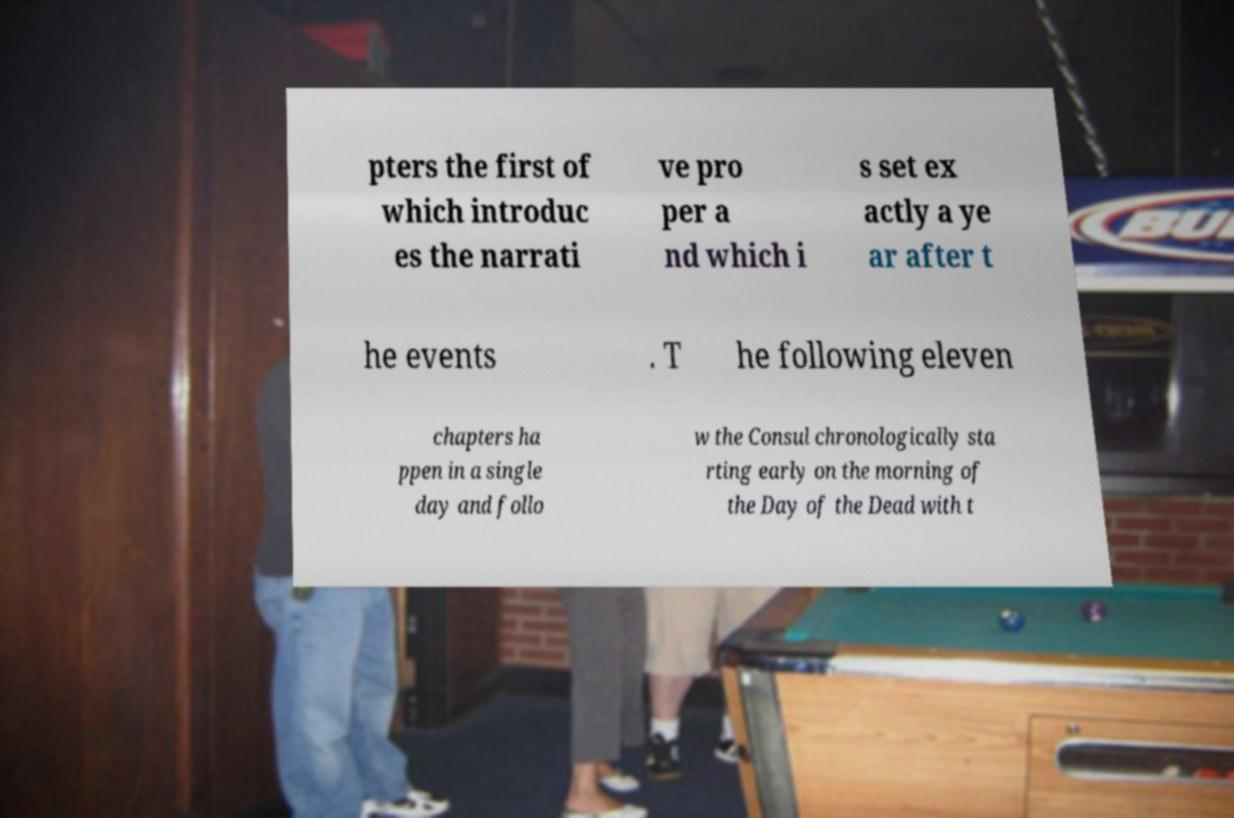What messages or text are displayed in this image? I need them in a readable, typed format. pters the first of which introduc es the narrati ve pro per a nd which i s set ex actly a ye ar after t he events . T he following eleven chapters ha ppen in a single day and follo w the Consul chronologically sta rting early on the morning of the Day of the Dead with t 